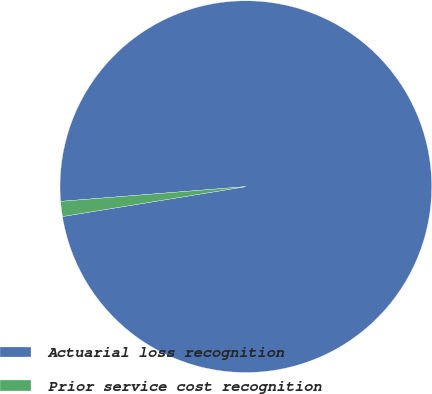Convert chart. <chart><loc_0><loc_0><loc_500><loc_500><pie_chart><fcel>Actuarial loss recognition<fcel>Prior service cost recognition<nl><fcel>98.69%<fcel>1.31%<nl></chart> 